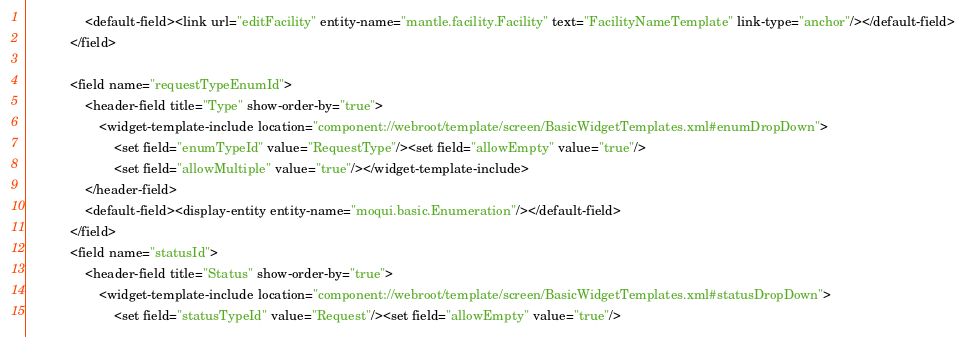<code> <loc_0><loc_0><loc_500><loc_500><_XML_>                <default-field><link url="editFacility" entity-name="mantle.facility.Facility" text="FacilityNameTemplate" link-type="anchor"/></default-field>
            </field>

            <field name="requestTypeEnumId">
                <header-field title="Type" show-order-by="true">
                    <widget-template-include location="component://webroot/template/screen/BasicWidgetTemplates.xml#enumDropDown">
                        <set field="enumTypeId" value="RequestType"/><set field="allowEmpty" value="true"/>
                        <set field="allowMultiple" value="true"/></widget-template-include>
                </header-field>
                <default-field><display-entity entity-name="moqui.basic.Enumeration"/></default-field>
            </field>
            <field name="statusId">
                <header-field title="Status" show-order-by="true">
                    <widget-template-include location="component://webroot/template/screen/BasicWidgetTemplates.xml#statusDropDown">
                        <set field="statusTypeId" value="Request"/><set field="allowEmpty" value="true"/></code> 